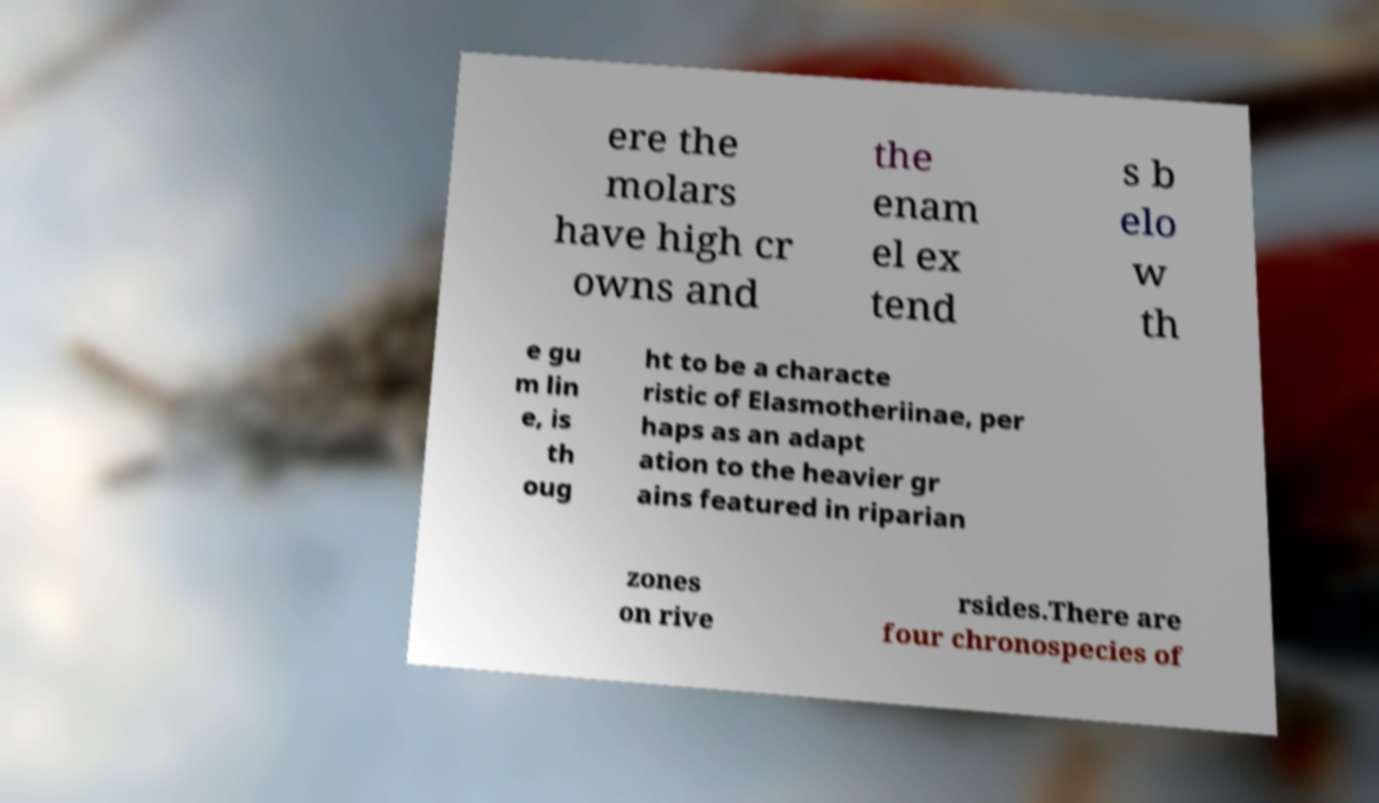Could you assist in decoding the text presented in this image and type it out clearly? ere the molars have high cr owns and the enam el ex tend s b elo w th e gu m lin e, is th oug ht to be a characte ristic of Elasmotheriinae, per haps as an adapt ation to the heavier gr ains featured in riparian zones on rive rsides.There are four chronospecies of 